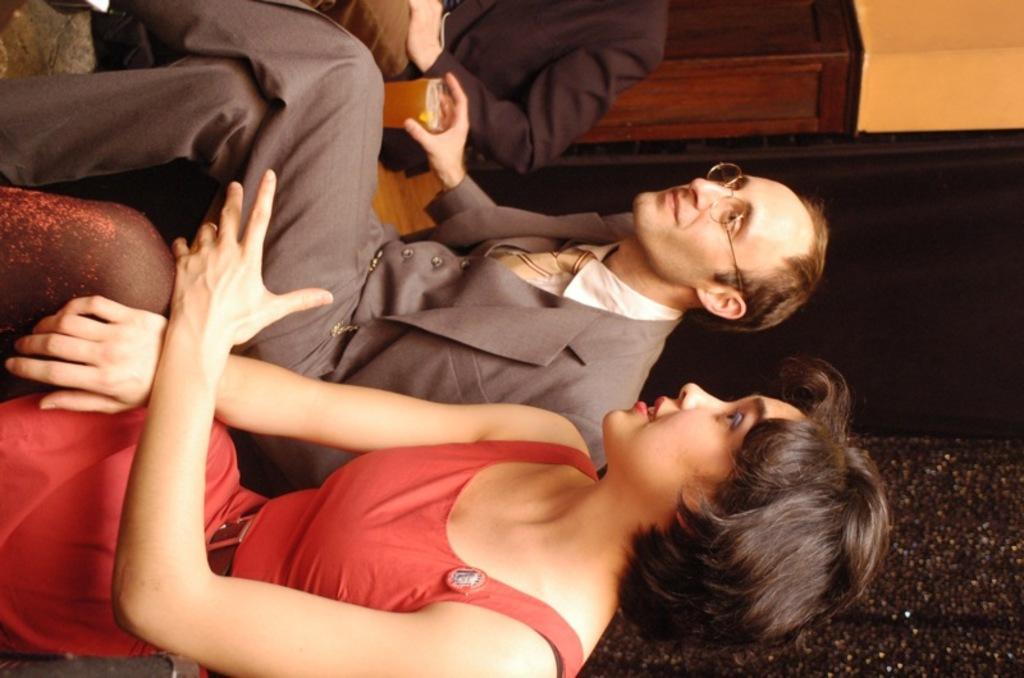Could you give a brief overview of what you see in this image? In the center of the image we can see two people are sitting and they are smiling, which we can see on their faces. And we can see the man holding one glass. In the background there is a wall, one person sitting and a few other objects. 